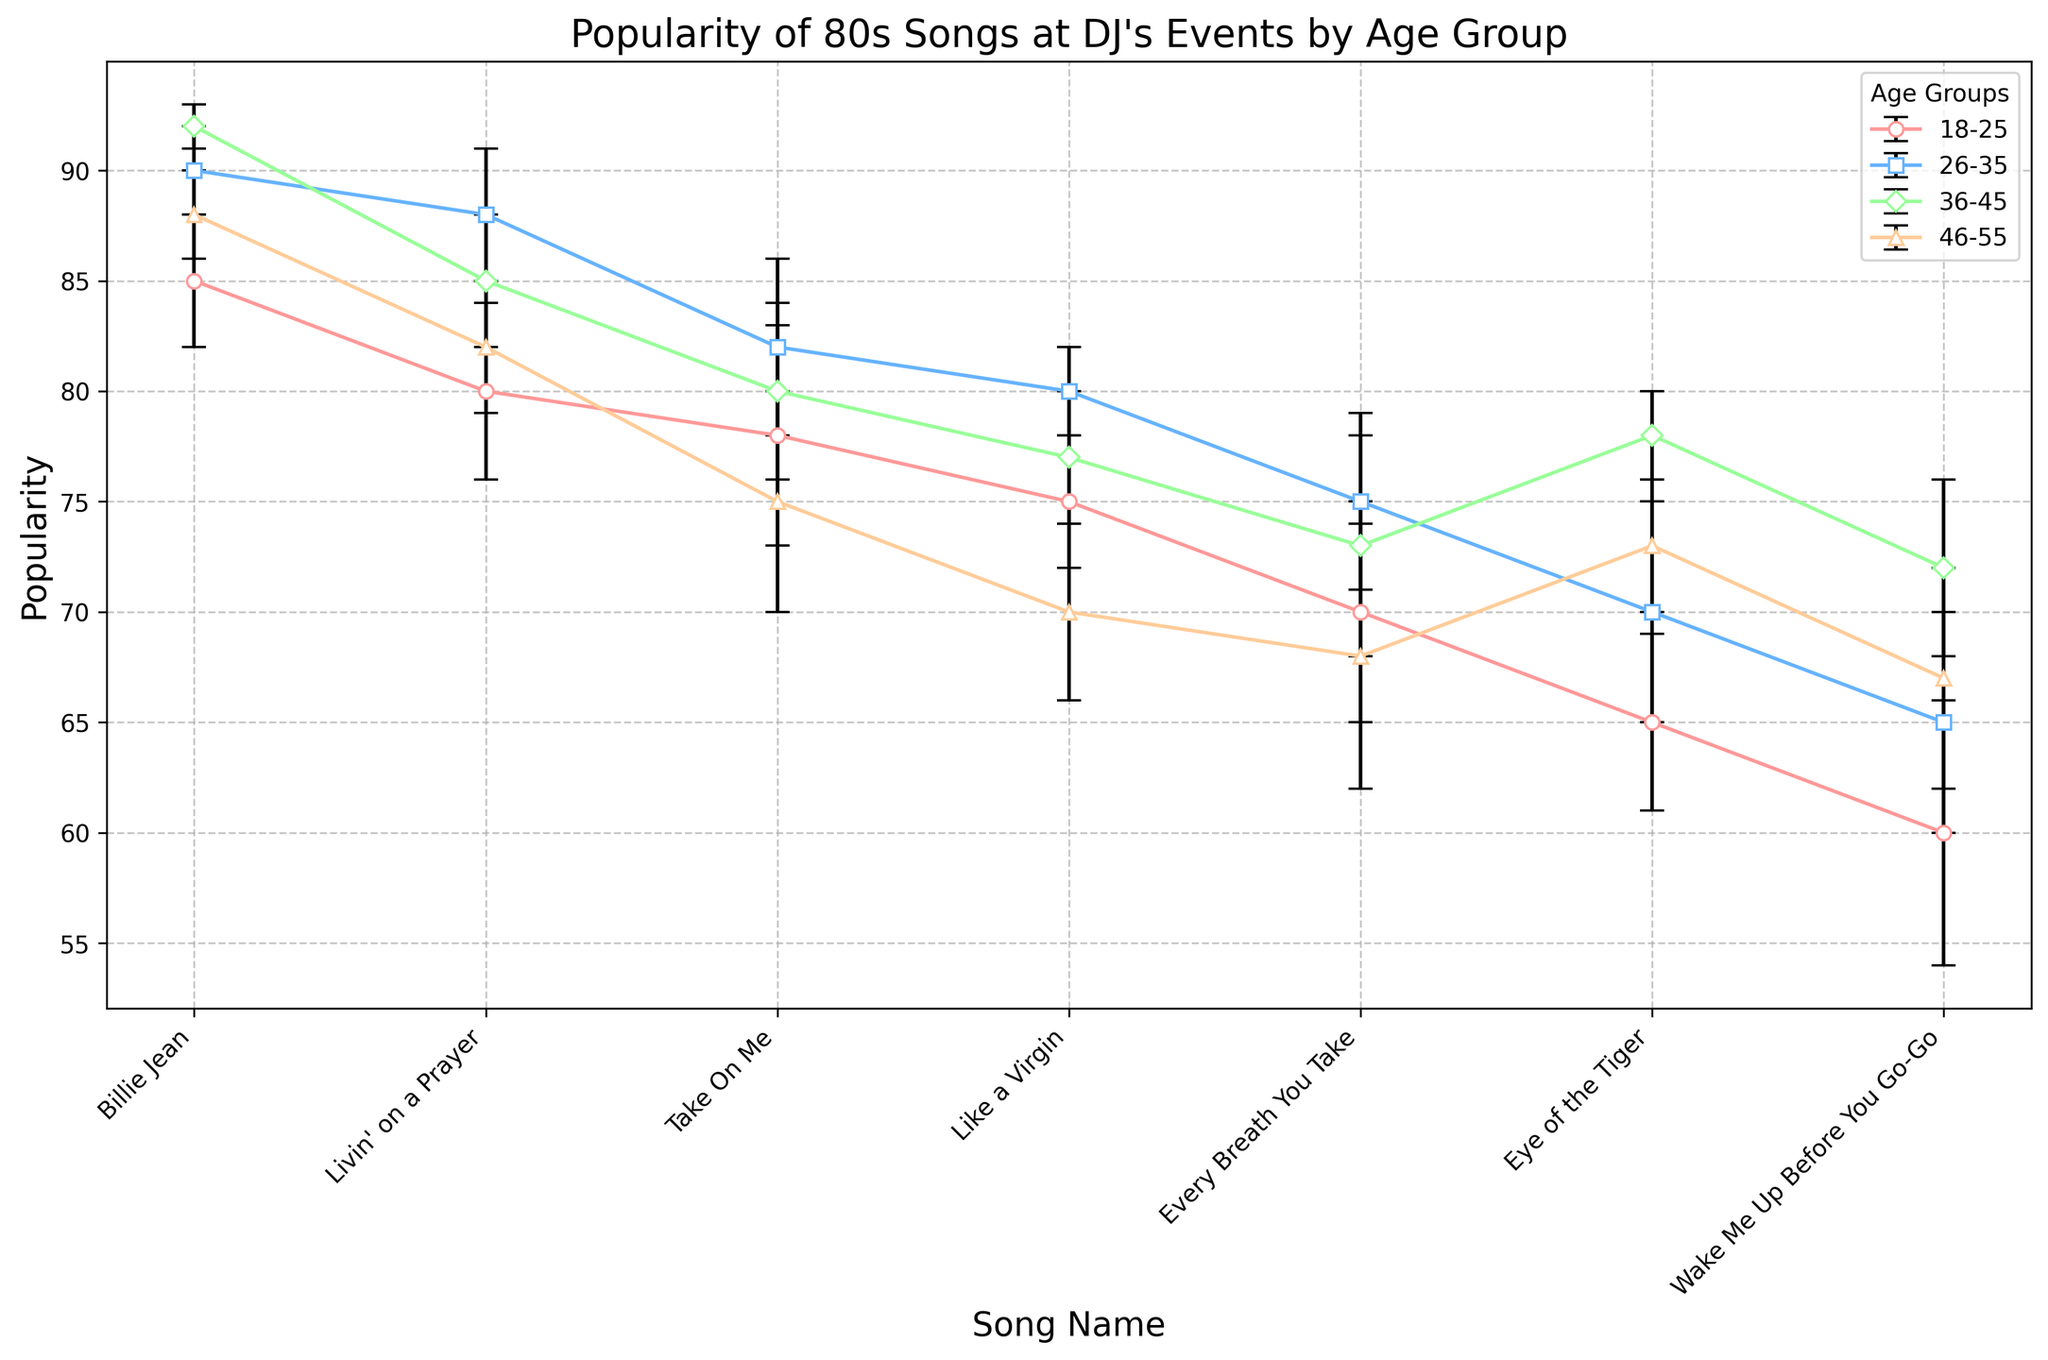Which age group rates "Billie Jean" the highest? To find the highest rating for "Billie Jean," check the height of the markers in the plot for each age group. The 36-45 age group has the highest marker.
Answer: 36-45 How does the popularity of "Wake Me Up Before You Go-Go" compare across age groups? Examine the markers for "Wake Me Up Before You Go-Go" for each age group. The 18-25 group rates it the lowest, and the 36-45 age group rates it the highest by popularity.
Answer: 36-45 > 26-35 > 46-55 > 18-25 Which song has the largest uncertainty in the 18-25 age group? Assess the error bars for each song in the 18-25 age group to see which extends the furthest. "Wake Me Up Before You Go-Go" has the longest error bars.
Answer: Wake Me Up Before You Go-Go Is "Eye of the Tiger" more popular among the 36-45 age group or the 18-25 age group? Compare the markers for "Eye of the Tiger" between the 36-45 and 18-25 age groups. The 36-45 group's marker is higher.
Answer: 36-45 What's the average popularity of "Livin' on a Prayer" across all age groups? Sum the popularity of "Livin' on a Prayer" for all age groups (80 + 88 + 85 + 82) and divide by the number of groups (4). (80 + 88 + 85 + 82) / 4 = 83.75
Answer: 83.75 Which song has the most consistent ranking across different age groups? Look for the song with the smallest uncertainties (error bars) across all age groups. "Billie Jean" has the smallest uncertainties overall.
Answer: Billie Jean How does the uncertainty in ranking for "Like a Virgin" vary across age groups? Check the length of the error bars for each age group rating "Like a Virgin." The uncertainties are 3, 2, 3, and 4 respectively.
Answer: 18-25: 3, 26-35: 2, 36-45: 3, 46-55: 4 Are there any songs where the 46-55 age group gives a higher popularity rating than the 18-25 age group? Compare each song's popularity markers between the 18-25 and 46-55 age groups. "Eye of the Tiger" and "Wake Me Up Before You Go-Go" are rated higher by the 46-55 age group.
Answer: Eye of the Tiger, Wake Me Up Before You Go-Go 